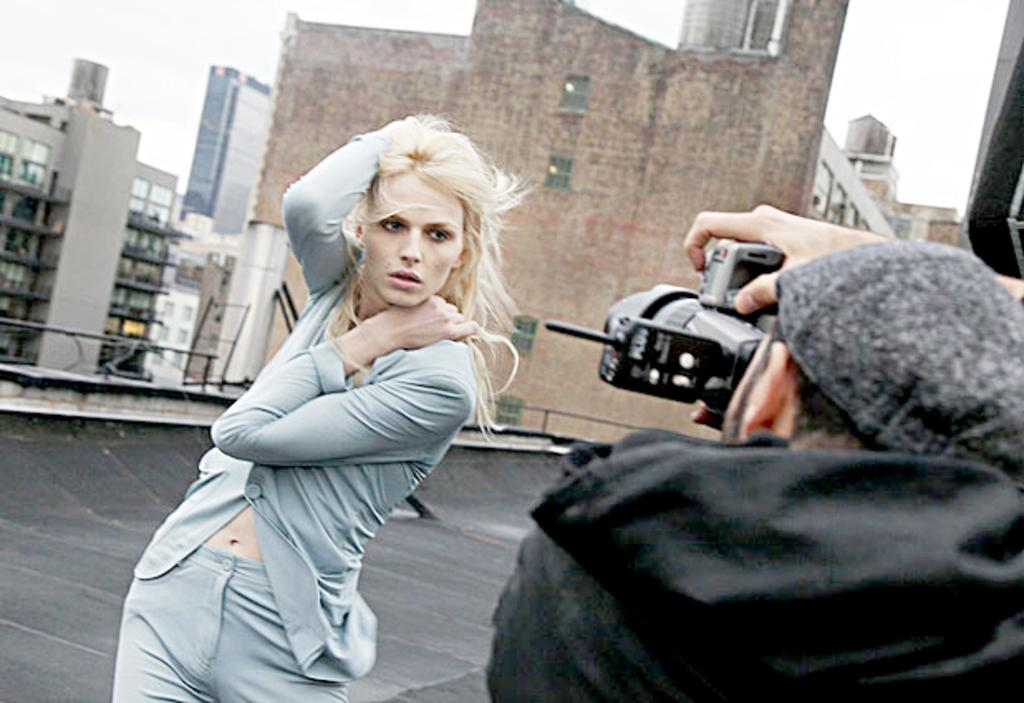What is the man in the image doing? The man in the image is taking a photo. Who is the subject of the photo being taken by the man? The woman in the image is being photographed by the man. What can be seen in the background of the image? There are buildings in the background of the image. What type of animal can be seen in the picture being taken by the man? There is no animal visible in the image, as the man is taking a photo of the woman. What spot is the woman standing on in the image? The provided facts do not mention a specific spot where the woman is standing; we only know that she is being photographed by the man. 